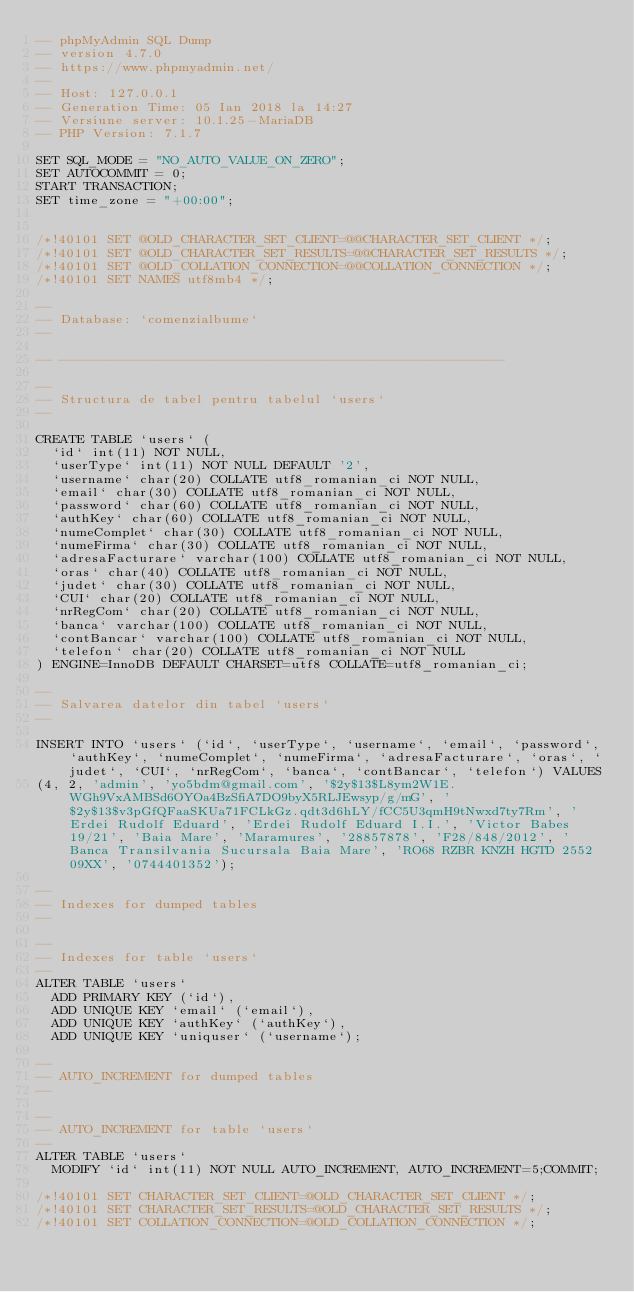<code> <loc_0><loc_0><loc_500><loc_500><_SQL_>-- phpMyAdmin SQL Dump
-- version 4.7.0
-- https://www.phpmyadmin.net/
--
-- Host: 127.0.0.1
-- Generation Time: 05 Ian 2018 la 14:27
-- Versiune server: 10.1.25-MariaDB
-- PHP Version: 7.1.7

SET SQL_MODE = "NO_AUTO_VALUE_ON_ZERO";
SET AUTOCOMMIT = 0;
START TRANSACTION;
SET time_zone = "+00:00";


/*!40101 SET @OLD_CHARACTER_SET_CLIENT=@@CHARACTER_SET_CLIENT */;
/*!40101 SET @OLD_CHARACTER_SET_RESULTS=@@CHARACTER_SET_RESULTS */;
/*!40101 SET @OLD_COLLATION_CONNECTION=@@COLLATION_CONNECTION */;
/*!40101 SET NAMES utf8mb4 */;

--
-- Database: `comenzialbume`
--

-- --------------------------------------------------------

--
-- Structura de tabel pentru tabelul `users`
--

CREATE TABLE `users` (
  `id` int(11) NOT NULL,
  `userType` int(11) NOT NULL DEFAULT '2',
  `username` char(20) COLLATE utf8_romanian_ci NOT NULL,
  `email` char(30) COLLATE utf8_romanian_ci NOT NULL,
  `password` char(60) COLLATE utf8_romanian_ci NOT NULL,
  `authKey` char(60) COLLATE utf8_romanian_ci NOT NULL,
  `numeComplet` char(30) COLLATE utf8_romanian_ci NOT NULL,
  `numeFirma` char(30) COLLATE utf8_romanian_ci NOT NULL,
  `adresaFacturare` varchar(100) COLLATE utf8_romanian_ci NOT NULL,
  `oras` char(40) COLLATE utf8_romanian_ci NOT NULL,
  `judet` char(30) COLLATE utf8_romanian_ci NOT NULL,
  `CUI` char(20) COLLATE utf8_romanian_ci NOT NULL,
  `nrRegCom` char(20) COLLATE utf8_romanian_ci NOT NULL,
  `banca` varchar(100) COLLATE utf8_romanian_ci NOT NULL,
  `contBancar` varchar(100) COLLATE utf8_romanian_ci NOT NULL,
  `telefon` char(20) COLLATE utf8_romanian_ci NOT NULL
) ENGINE=InnoDB DEFAULT CHARSET=utf8 COLLATE=utf8_romanian_ci;

--
-- Salvarea datelor din tabel `users`
--

INSERT INTO `users` (`id`, `userType`, `username`, `email`, `password`, `authKey`, `numeComplet`, `numeFirma`, `adresaFacturare`, `oras`, `judet`, `CUI`, `nrRegCom`, `banca`, `contBancar`, `telefon`) VALUES
(4, 2, 'admin', 'yo5bdm@gmail.com', '$2y$13$L8ym2W1E.WGh9VxAMBSd6OYOa4BzSfiA7DO9byX5RLJEwsyp/g/mG', '$2y$13$v3pGfQFaaSKUa71FCLkGz.qdt3d6hLY/fCC5U3qmH9tNwxd7ty7Rm', 'Erdei Rudolf Eduard', 'Erdei Rudolf Eduard I.I.', 'Victor Babes 19/21', 'Baia Mare', 'Maramures', '28857878', 'F28/848/2012', 'Banca Transilvania Sucursala Baia Mare', 'RO68 RZBR KNZH HGTD 2552 09XX', '0744401352');

--
-- Indexes for dumped tables
--

--
-- Indexes for table `users`
--
ALTER TABLE `users`
  ADD PRIMARY KEY (`id`),
  ADD UNIQUE KEY `email` (`email`),
  ADD UNIQUE KEY `authKey` (`authKey`),
  ADD UNIQUE KEY `uniquser` (`username`);

--
-- AUTO_INCREMENT for dumped tables
--

--
-- AUTO_INCREMENT for table `users`
--
ALTER TABLE `users`
  MODIFY `id` int(11) NOT NULL AUTO_INCREMENT, AUTO_INCREMENT=5;COMMIT;

/*!40101 SET CHARACTER_SET_CLIENT=@OLD_CHARACTER_SET_CLIENT */;
/*!40101 SET CHARACTER_SET_RESULTS=@OLD_CHARACTER_SET_RESULTS */;
/*!40101 SET COLLATION_CONNECTION=@OLD_COLLATION_CONNECTION */;
</code> 